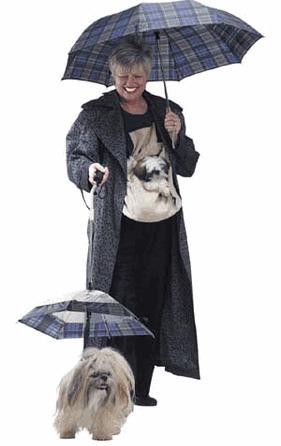How many umbrellas are there in the image?
Be succinct. 2. Is the photo colored?
Concise answer only. Yes. How many dogs are in the image?
Write a very short answer. 2. 